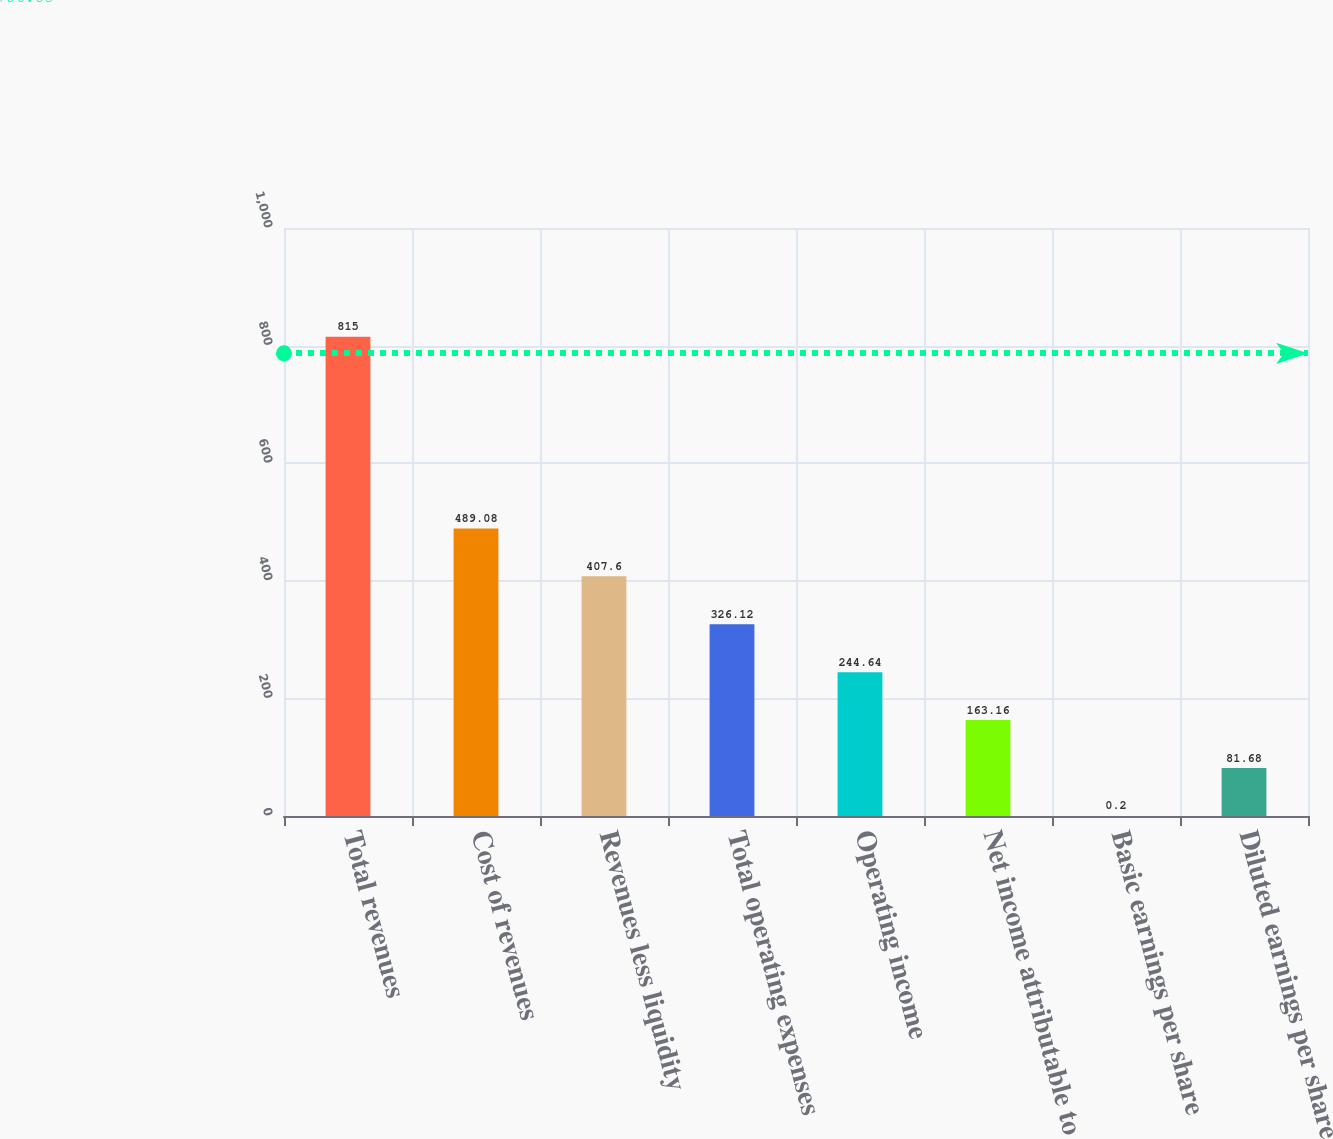<chart> <loc_0><loc_0><loc_500><loc_500><bar_chart><fcel>Total revenues<fcel>Cost of revenues<fcel>Revenues less liquidity<fcel>Total operating expenses<fcel>Operating income<fcel>Net income attributable to<fcel>Basic earnings per share<fcel>Diluted earnings per share<nl><fcel>815<fcel>489.08<fcel>407.6<fcel>326.12<fcel>244.64<fcel>163.16<fcel>0.2<fcel>81.68<nl></chart> 